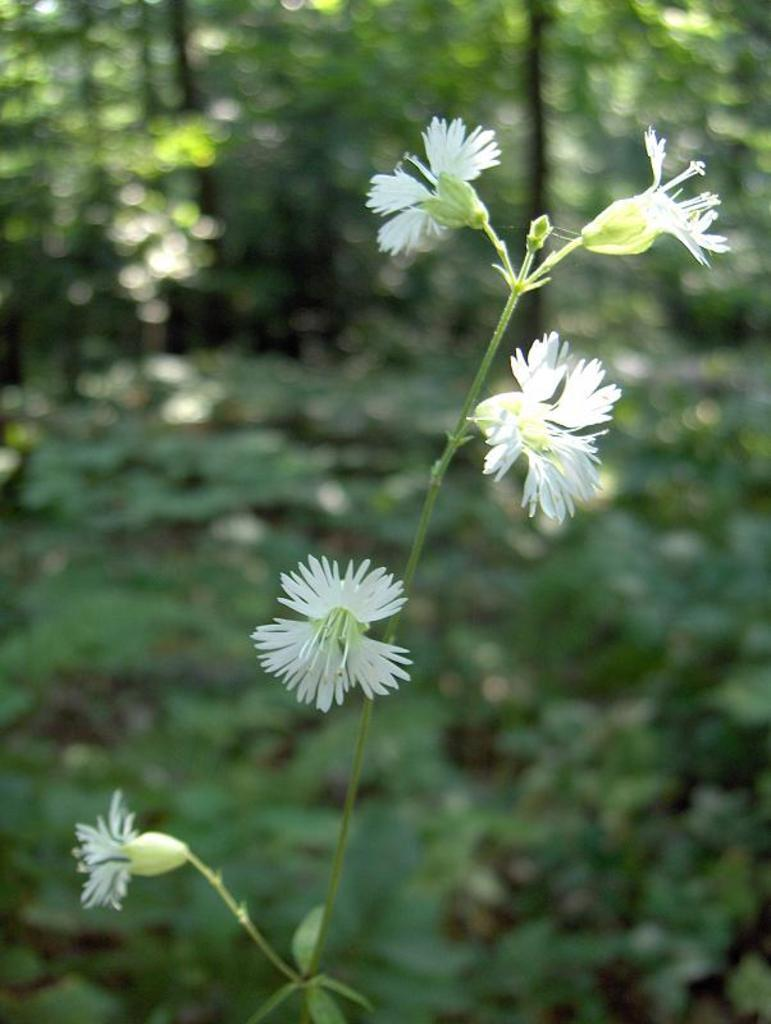What type of flowers can be seen on the plant in the image? There are white color flowers on a plant in the image. What can be seen in the distance behind the plant? There are many trees visible in the background of the image. How would you describe the appearance of the background? The background appears blurry. What type of potato is being carried in the manager's pocket in the image? There is no potato or manager present in the image. 